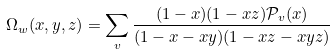Convert formula to latex. <formula><loc_0><loc_0><loc_500><loc_500>\Omega _ { w } ( x , y , z ) = \sum _ { v } \frac { ( 1 - x ) ( 1 - x z ) \mathcal { P } _ { v } ( x ) } { ( 1 - x - x y ) ( 1 - x z - x y z ) }</formula> 